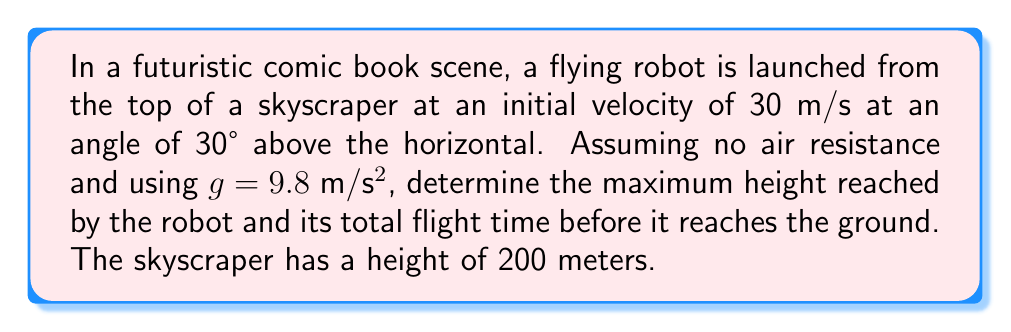Can you answer this question? Let's approach this problem step-by-step:

1) First, let's break down the initial velocity into its horizontal and vertical components:
   $$v_{0x} = v_0 \cos \theta = 30 \cos 30° = 30 \cdot \frac{\sqrt{3}}{2} = 15\sqrt{3} \text{ m/s}$$
   $$v_{0y} = v_0 \sin \theta = 30 \sin 30° = 30 \cdot \frac{1}{2} = 15 \text{ m/s}$$

2) The time to reach maximum height can be calculated using the equation:
   $$v_y = v_{0y} - gt$$
   At the highest point, $v_y = 0$, so:
   $$0 = 15 - 9.8t$$
   $$t = \frac{15}{9.8} = 1.53 \text{ s}$$

3) The maximum height reached above the launch point can be calculated using:
   $$y = v_{0y}t - \frac{1}{2}gt^2$$
   $$y = 15 \cdot 1.53 - \frac{1}{2} \cdot 9.8 \cdot 1.53^2 = 11.48 \text{ m}$$

4) The total height reached is the sum of the skyscraper's height and this additional height:
   $$h_{total} = 200 + 11.48 = 211.48 \text{ m}$$

5) For the total flight time, we need to consider the time to go up and come down. The time to come down from the maximum height to the ground level can be calculated using:
   $$y = -\frac{1}{2}gt^2$$
   $$211.48 = \frac{1}{2} \cdot 9.8 \cdot t^2$$
   $$t = \sqrt{\frac{2 \cdot 211.48}{9.8}} = 6.57 \text{ s}$$

6) The total flight time is the sum of time to go up and time to come down:
   $$t_{total} = 1.53 + 6.57 = 8.1 \text{ s}$$

[asy]
import geometry;

size(200);
pair O=(0,0);
pair A=(0,200);
pair B=(100,211.48);
pair C=(200,0);

draw(O--A--B--C,Arrow);
draw(A--C,dashed);

label("Ground", (100,-5));
label("200 m", (-5,100), W);
label("11.48 m", (50,206), N);
label("Skyscraper", (-5,100), W);

dot("Launch point", A, NW);
dot("Max height", B, N);
dot("Landing point", C, SE);
[/asy]
Answer: Maximum height: 211.48 m; Total flight time: 8.1 s 